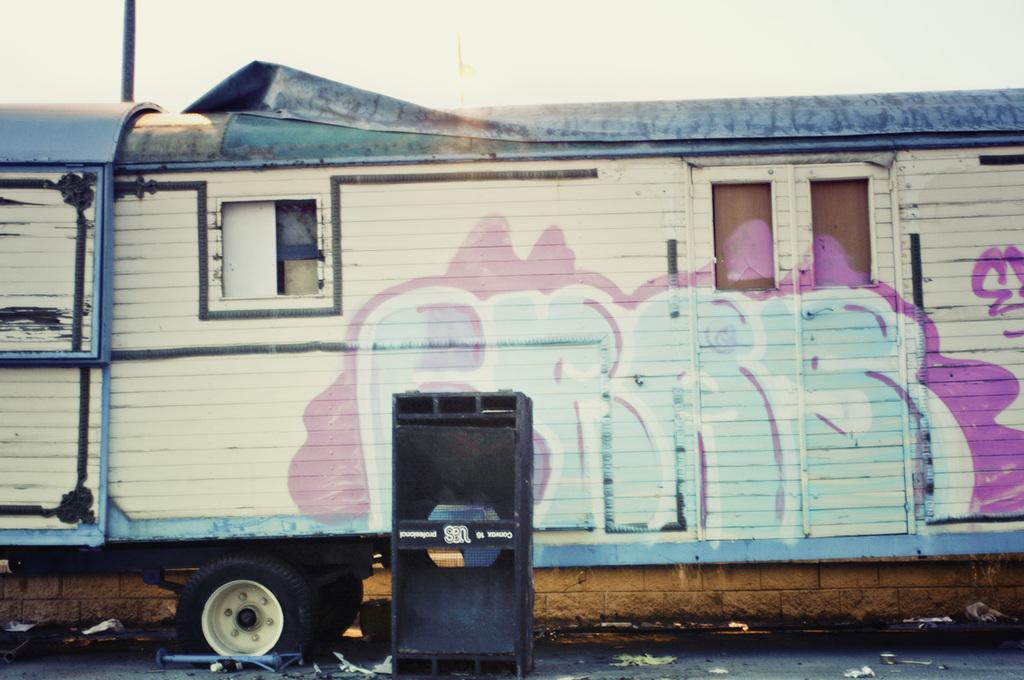How would you summarize this image in a sentence or two? As we can see in the image there is a train, sound box, window, door and sky. 